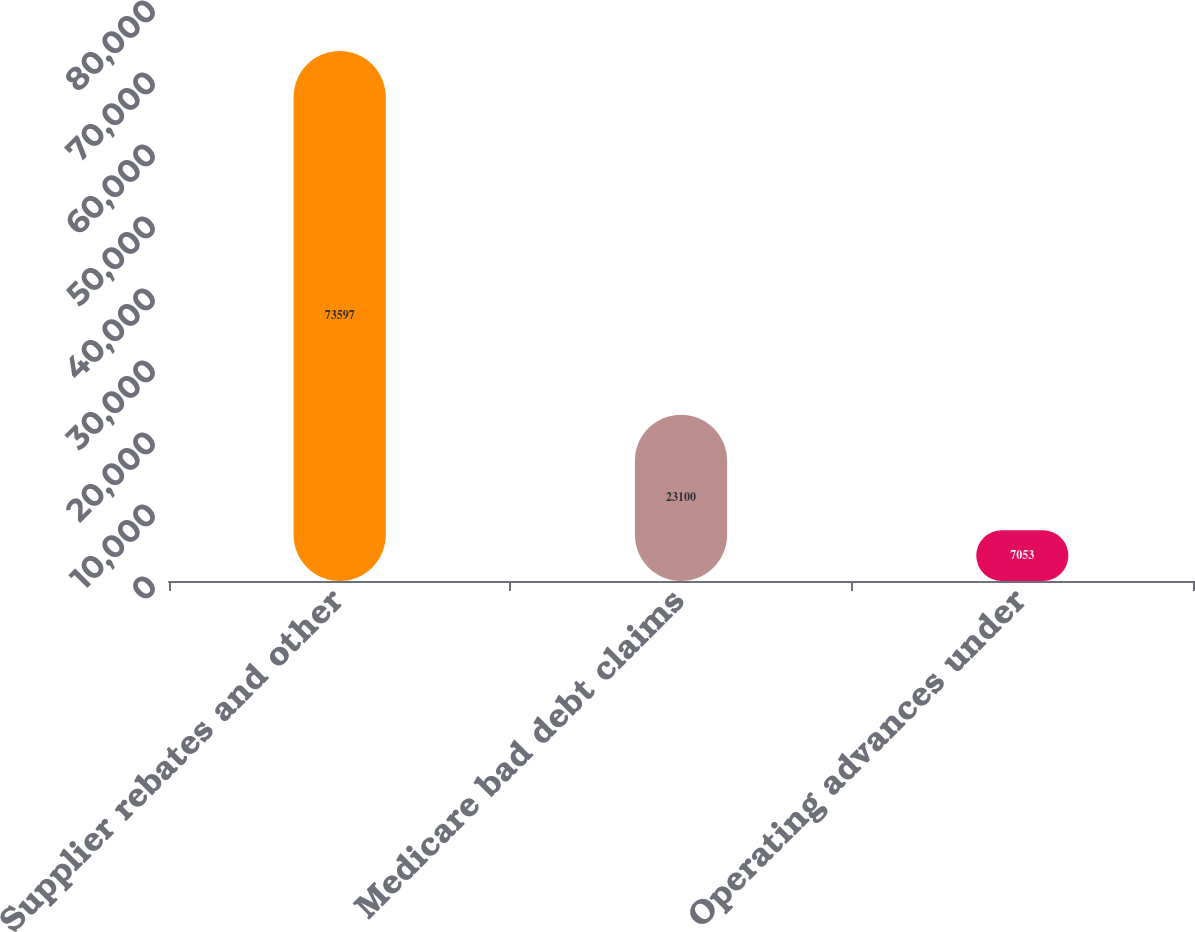Convert chart. <chart><loc_0><loc_0><loc_500><loc_500><bar_chart><fcel>Supplier rebates and other<fcel>Medicare bad debt claims<fcel>Operating advances under<nl><fcel>73597<fcel>23100<fcel>7053<nl></chart> 